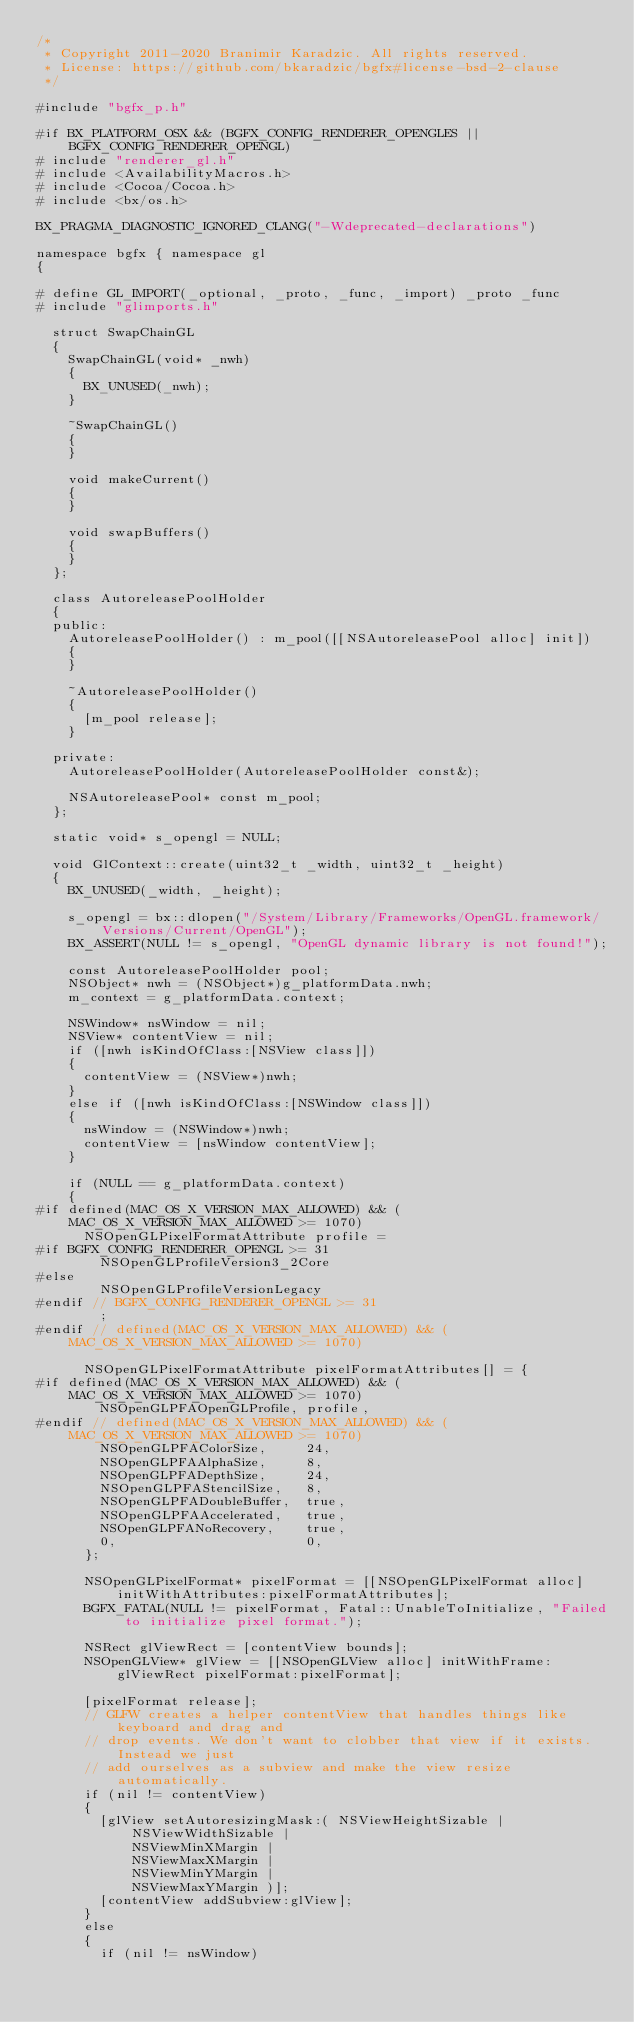<code> <loc_0><loc_0><loc_500><loc_500><_ObjectiveC_>/*
 * Copyright 2011-2020 Branimir Karadzic. All rights reserved.
 * License: https://github.com/bkaradzic/bgfx#license-bsd-2-clause
 */

#include "bgfx_p.h"

#if BX_PLATFORM_OSX && (BGFX_CONFIG_RENDERER_OPENGLES || BGFX_CONFIG_RENDERER_OPENGL)
#	include "renderer_gl.h"
#	include <AvailabilityMacros.h>
#	include <Cocoa/Cocoa.h>
#	include <bx/os.h>

BX_PRAGMA_DIAGNOSTIC_IGNORED_CLANG("-Wdeprecated-declarations")

namespace bgfx { namespace gl
{

#	define GL_IMPORT(_optional, _proto, _func, _import) _proto _func
#	include "glimports.h"

	struct SwapChainGL
	{
		SwapChainGL(void* _nwh)
		{
			BX_UNUSED(_nwh);
		}

		~SwapChainGL()
		{
		}

		void makeCurrent()
		{
		}

		void swapBuffers()
		{
		}
	};

	class AutoreleasePoolHolder
	{
	public:
		AutoreleasePoolHolder() : m_pool([[NSAutoreleasePool alloc] init])
		{
		}

		~AutoreleasePoolHolder()
		{
			[m_pool release];
		}

	private:
		AutoreleasePoolHolder(AutoreleasePoolHolder const&);

		NSAutoreleasePool* const m_pool;
	};

	static void* s_opengl = NULL;

	void GlContext::create(uint32_t _width, uint32_t _height)
	{
		BX_UNUSED(_width, _height);

		s_opengl = bx::dlopen("/System/Library/Frameworks/OpenGL.framework/Versions/Current/OpenGL");
		BX_ASSERT(NULL != s_opengl, "OpenGL dynamic library is not found!");

		const AutoreleasePoolHolder pool;
		NSObject* nwh = (NSObject*)g_platformData.nwh;
		m_context = g_platformData.context;

		NSWindow* nsWindow = nil;
		NSView* contentView = nil;
		if ([nwh isKindOfClass:[NSView class]])
		{
			contentView = (NSView*)nwh;
		}
		else if ([nwh isKindOfClass:[NSWindow class]])
		{
			nsWindow = (NSWindow*)nwh;
			contentView = [nsWindow contentView];
		}

		if (NULL == g_platformData.context)
		{
#if defined(MAC_OS_X_VERSION_MAX_ALLOWED) && (MAC_OS_X_VERSION_MAX_ALLOWED >= 1070)
			NSOpenGLPixelFormatAttribute profile =
#if BGFX_CONFIG_RENDERER_OPENGL >= 31
				NSOpenGLProfileVersion3_2Core
#else
				NSOpenGLProfileVersionLegacy
#endif // BGFX_CONFIG_RENDERER_OPENGL >= 31
				;
#endif // defined(MAC_OS_X_VERSION_MAX_ALLOWED) && (MAC_OS_X_VERSION_MAX_ALLOWED >= 1070)

			NSOpenGLPixelFormatAttribute pixelFormatAttributes[] = {
#if defined(MAC_OS_X_VERSION_MAX_ALLOWED) && (MAC_OS_X_VERSION_MAX_ALLOWED >= 1070)
				NSOpenGLPFAOpenGLProfile, profile,
#endif // defined(MAC_OS_X_VERSION_MAX_ALLOWED) && (MAC_OS_X_VERSION_MAX_ALLOWED >= 1070)
				NSOpenGLPFAColorSize,     24,
				NSOpenGLPFAAlphaSize,     8,
				NSOpenGLPFADepthSize,     24,
				NSOpenGLPFAStencilSize,   8,
				NSOpenGLPFADoubleBuffer,  true,
				NSOpenGLPFAAccelerated,   true,
				NSOpenGLPFANoRecovery,    true,
				0,                        0,
			};

			NSOpenGLPixelFormat* pixelFormat = [[NSOpenGLPixelFormat alloc] initWithAttributes:pixelFormatAttributes];
			BGFX_FATAL(NULL != pixelFormat, Fatal::UnableToInitialize, "Failed to initialize pixel format.");

			NSRect glViewRect = [contentView bounds];
			NSOpenGLView* glView = [[NSOpenGLView alloc] initWithFrame:glViewRect pixelFormat:pixelFormat];

			[pixelFormat release];
			// GLFW creates a helper contentView that handles things like keyboard and drag and
			// drop events. We don't want to clobber that view if it exists. Instead we just
			// add ourselves as a subview and make the view resize automatically.
			if (nil != contentView)
			{
				[glView setAutoresizingMask:( NSViewHeightSizable |
						NSViewWidthSizable |
						NSViewMinXMargin |
						NSViewMaxXMargin |
						NSViewMinYMargin |
						NSViewMaxYMargin )];
				[contentView addSubview:glView];
			}
			else
			{
				if (nil != nsWindow)</code> 